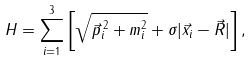<formula> <loc_0><loc_0><loc_500><loc_500>H = \sum ^ { 3 } _ { i = 1 } \left [ \sqrt { \vec { p } ^ { \, 2 } _ { i } + m ^ { 2 } _ { i } } + \sigma | \vec { x } _ { i } - \vec { R } | \right ] ,</formula> 